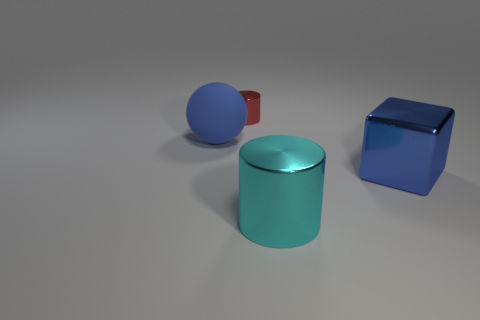There is a cyan thing that is the same shape as the red metal thing; what material is it?
Your response must be concise. Metal. What is the color of the small shiny cylinder?
Give a very brief answer. Red. Is the color of the large metal cube the same as the sphere?
Make the answer very short. Yes. What number of metallic objects are either small blue things or large blue spheres?
Your answer should be very brief. 0. There is a shiny object behind the blue thing to the left of the red metal cylinder; is there a large cyan metallic thing behind it?
Offer a very short reply. No. What is the size of the cube that is the same material as the big cyan cylinder?
Keep it short and to the point. Large. There is a large blue metal block; are there any matte things on the right side of it?
Your answer should be compact. No. There is a large metal cylinder in front of the big cube; are there any blue shiny objects right of it?
Your response must be concise. Yes. There is a shiny cylinder behind the large blue ball; does it have the same size as the blue thing that is on the left side of the large cyan metallic thing?
Your response must be concise. No. What number of big objects are either metallic cylinders or yellow metallic cylinders?
Keep it short and to the point. 1. 